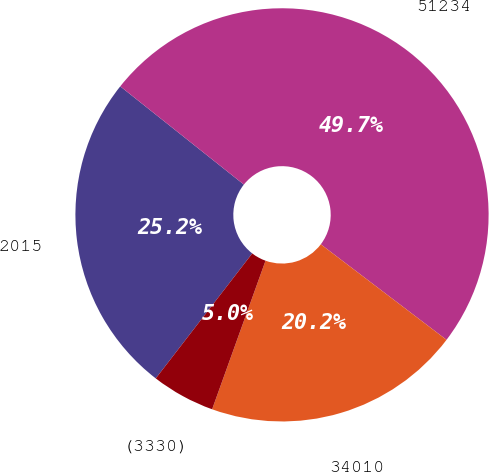<chart> <loc_0><loc_0><loc_500><loc_500><pie_chart><fcel>2015<fcel>51234<fcel>34010<fcel>(3330)<nl><fcel>25.22%<fcel>49.65%<fcel>20.15%<fcel>4.97%<nl></chart> 